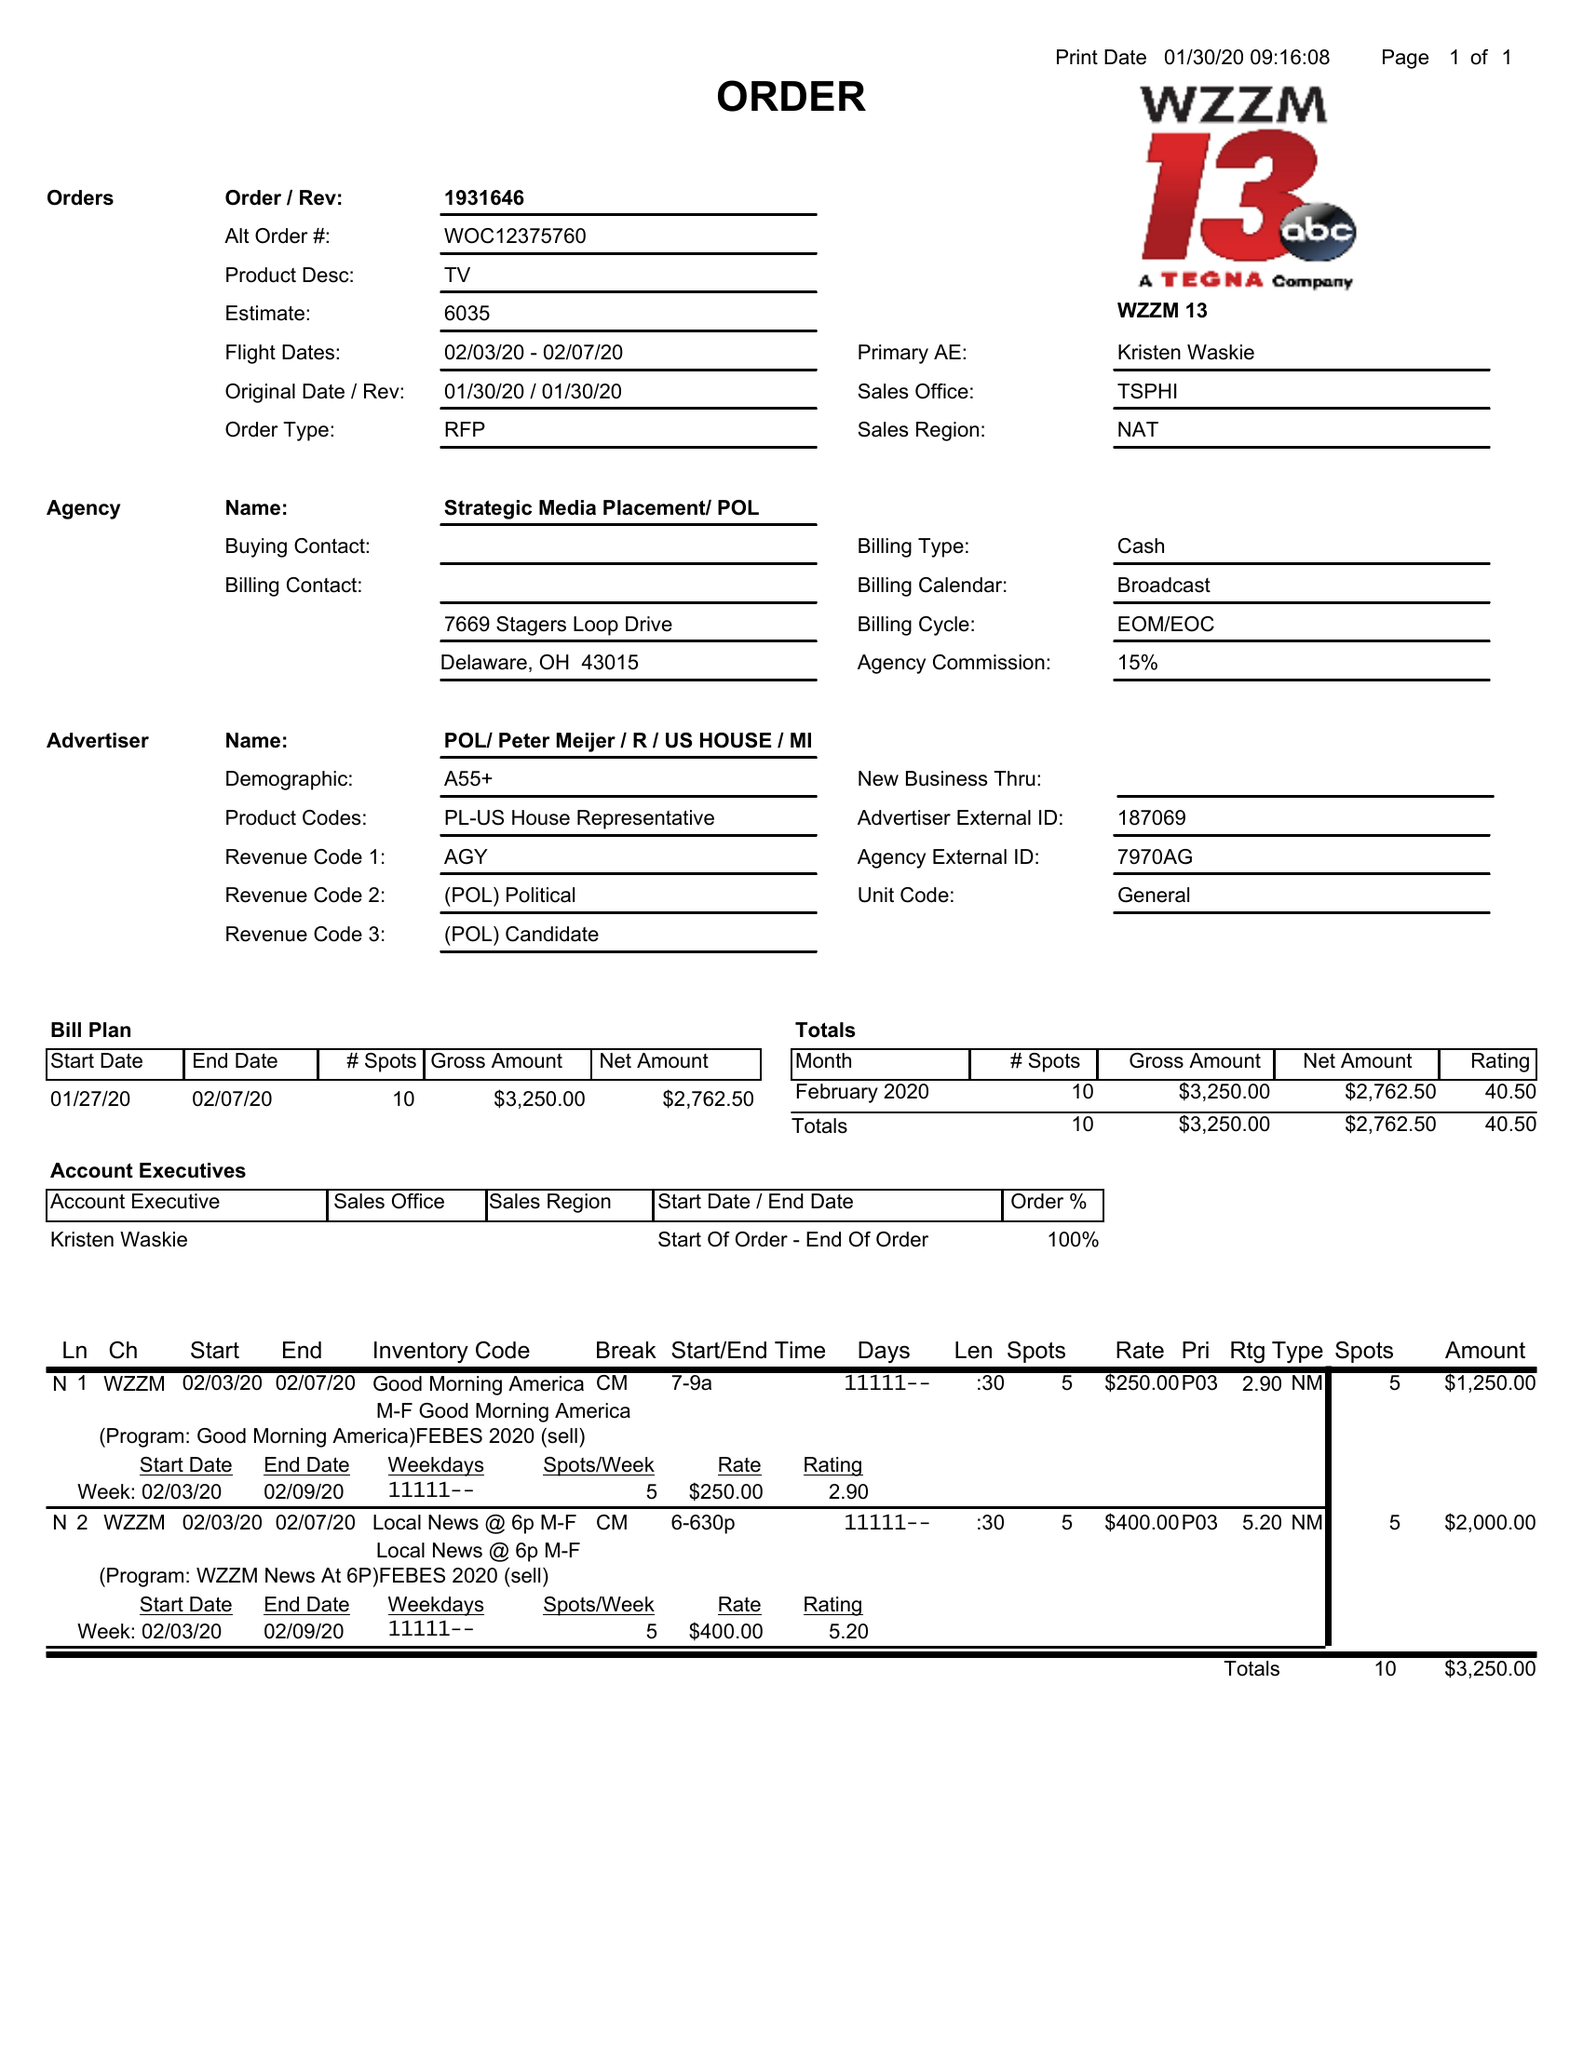What is the value for the contract_num?
Answer the question using a single word or phrase. 1931646 